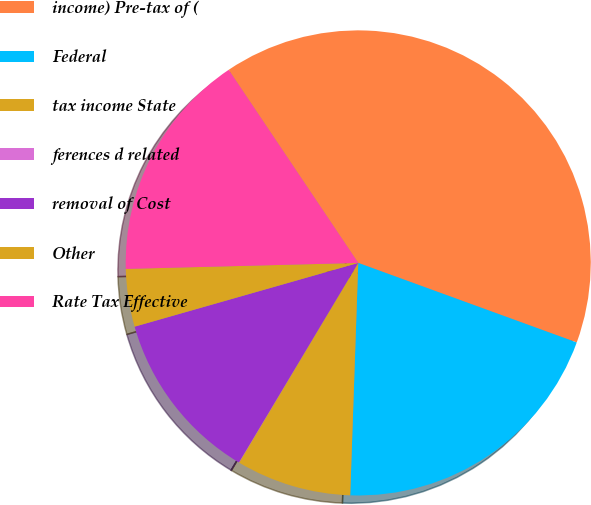Convert chart. <chart><loc_0><loc_0><loc_500><loc_500><pie_chart><fcel>income) Pre-tax of (<fcel>Federal<fcel>tax income State<fcel>ferences d related<fcel>removal of Cost<fcel>Other<fcel>Rate Tax Effective<nl><fcel>39.96%<fcel>19.99%<fcel>8.01%<fcel>0.02%<fcel>12.0%<fcel>4.01%<fcel>16.0%<nl></chart> 